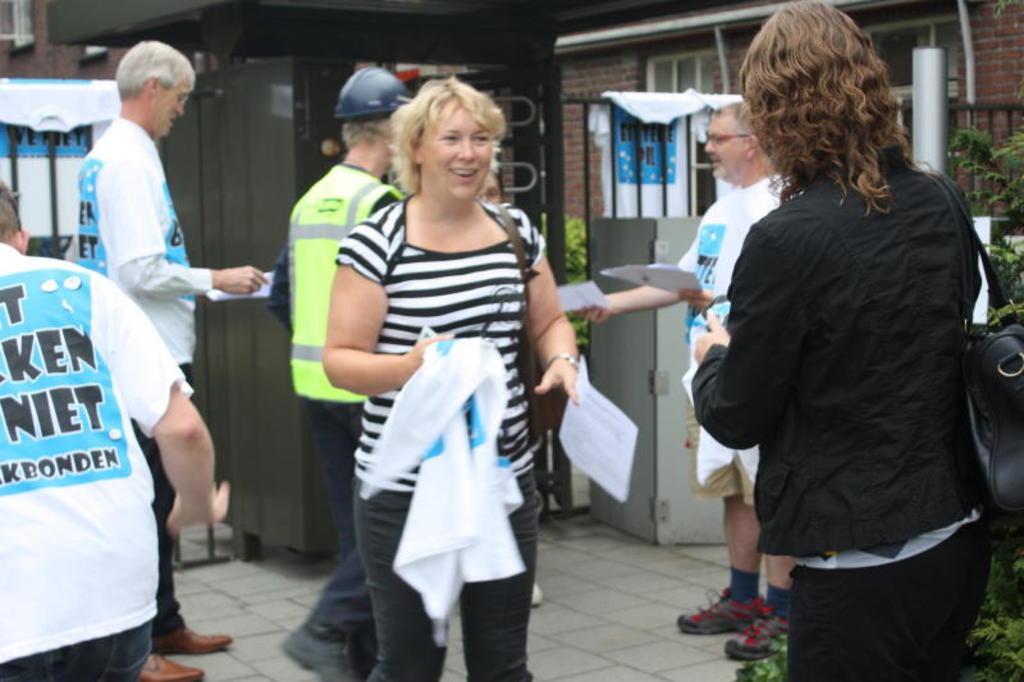Could you give a brief overview of what you see in this image? In this image we can see a few people standing and holding the objects, there are some plants, buildings, clothes, fence and some other objects on the ground. 